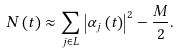Convert formula to latex. <formula><loc_0><loc_0><loc_500><loc_500>N \left ( t \right ) \approx \sum _ { j \in L } \left | \alpha _ { j } \left ( t \right ) \right | ^ { 2 } - \frac { M } { 2 } .</formula> 